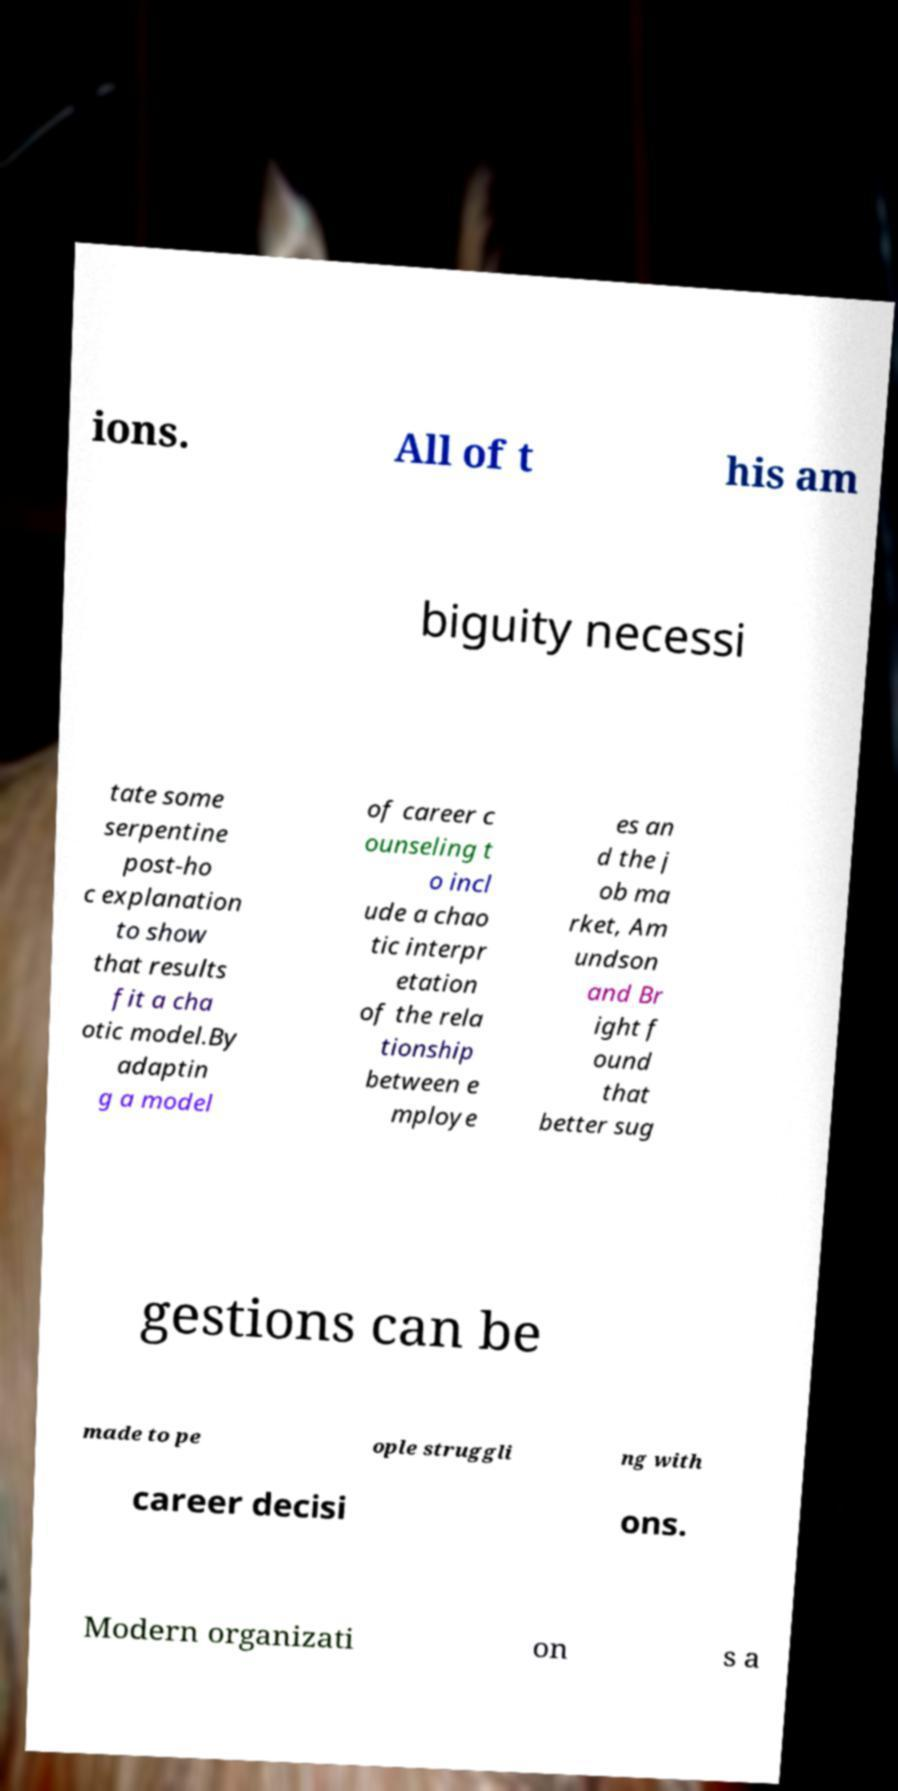Can you read and provide the text displayed in the image?This photo seems to have some interesting text. Can you extract and type it out for me? ions. All of t his am biguity necessi tate some serpentine post-ho c explanation to show that results fit a cha otic model.By adaptin g a model of career c ounseling t o incl ude a chao tic interpr etation of the rela tionship between e mploye es an d the j ob ma rket, Am undson and Br ight f ound that better sug gestions can be made to pe ople struggli ng with career decisi ons. Modern organizati on s a 